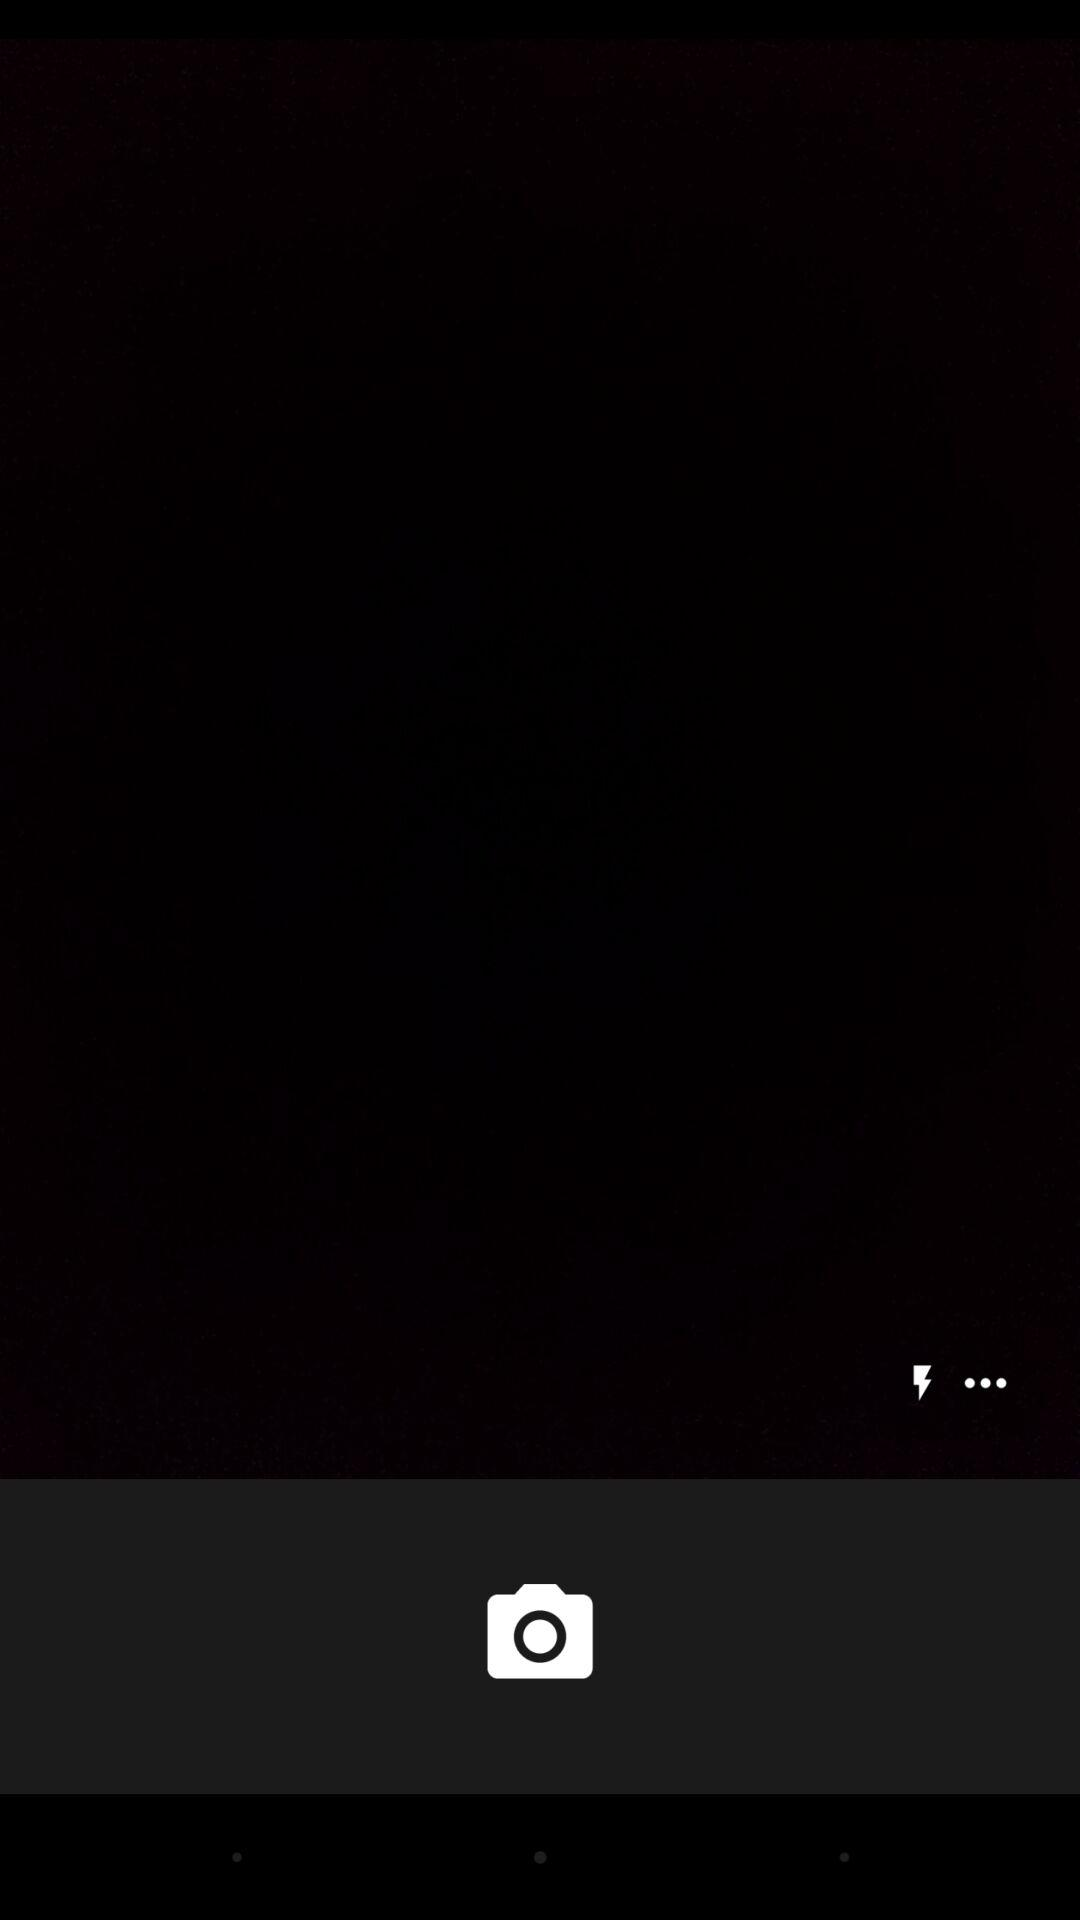How many more dots are there than the lightning bolt?
Answer the question using a single word or phrase. 2 